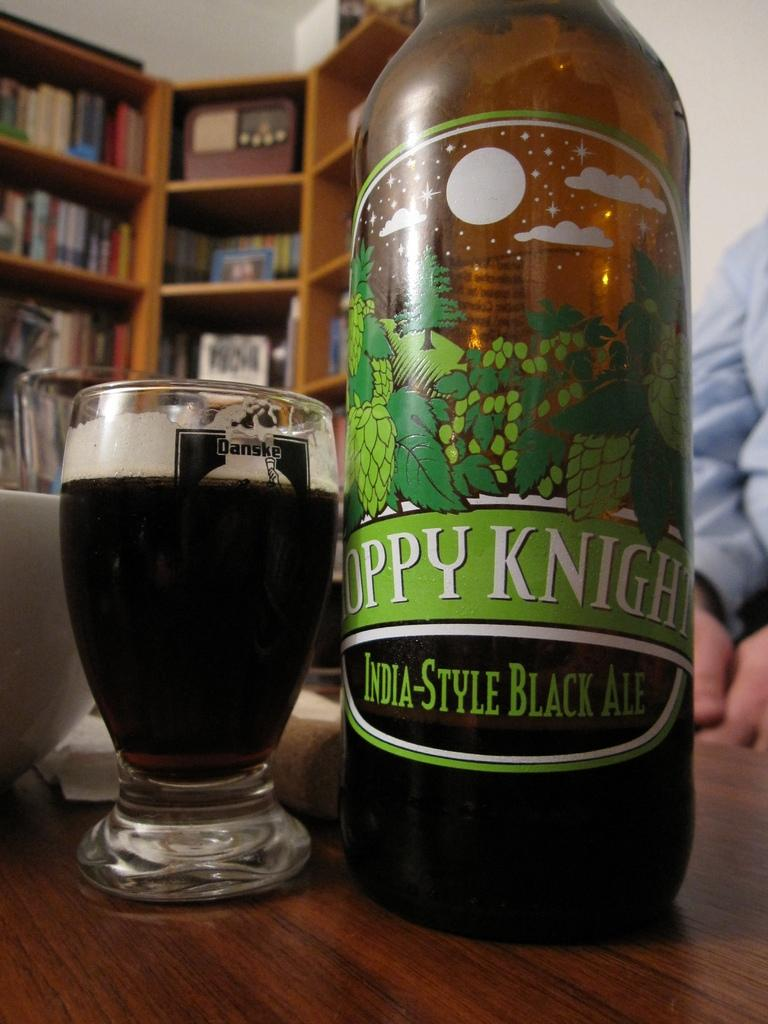<image>
Describe the image concisely. an India style black ale bottle above some wood 